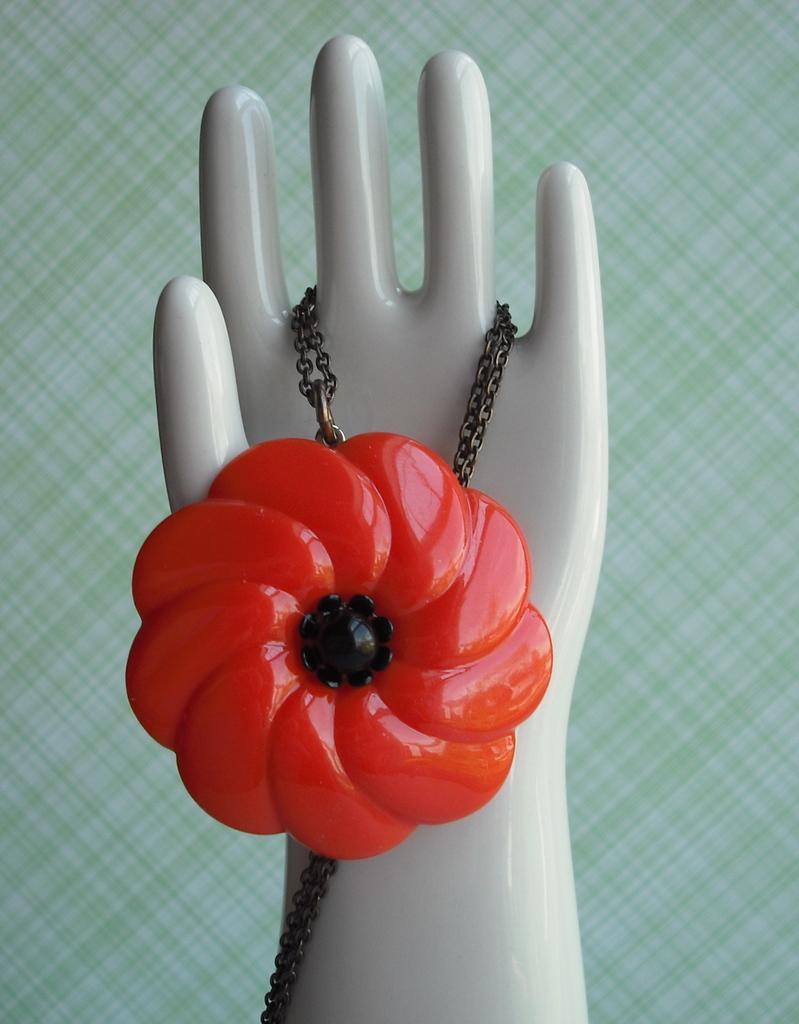Please provide a concise description of this image. In the middle of the image there is a chain with a red colored locket on the mannequin hand. In the background there is a surface with many stripes. 